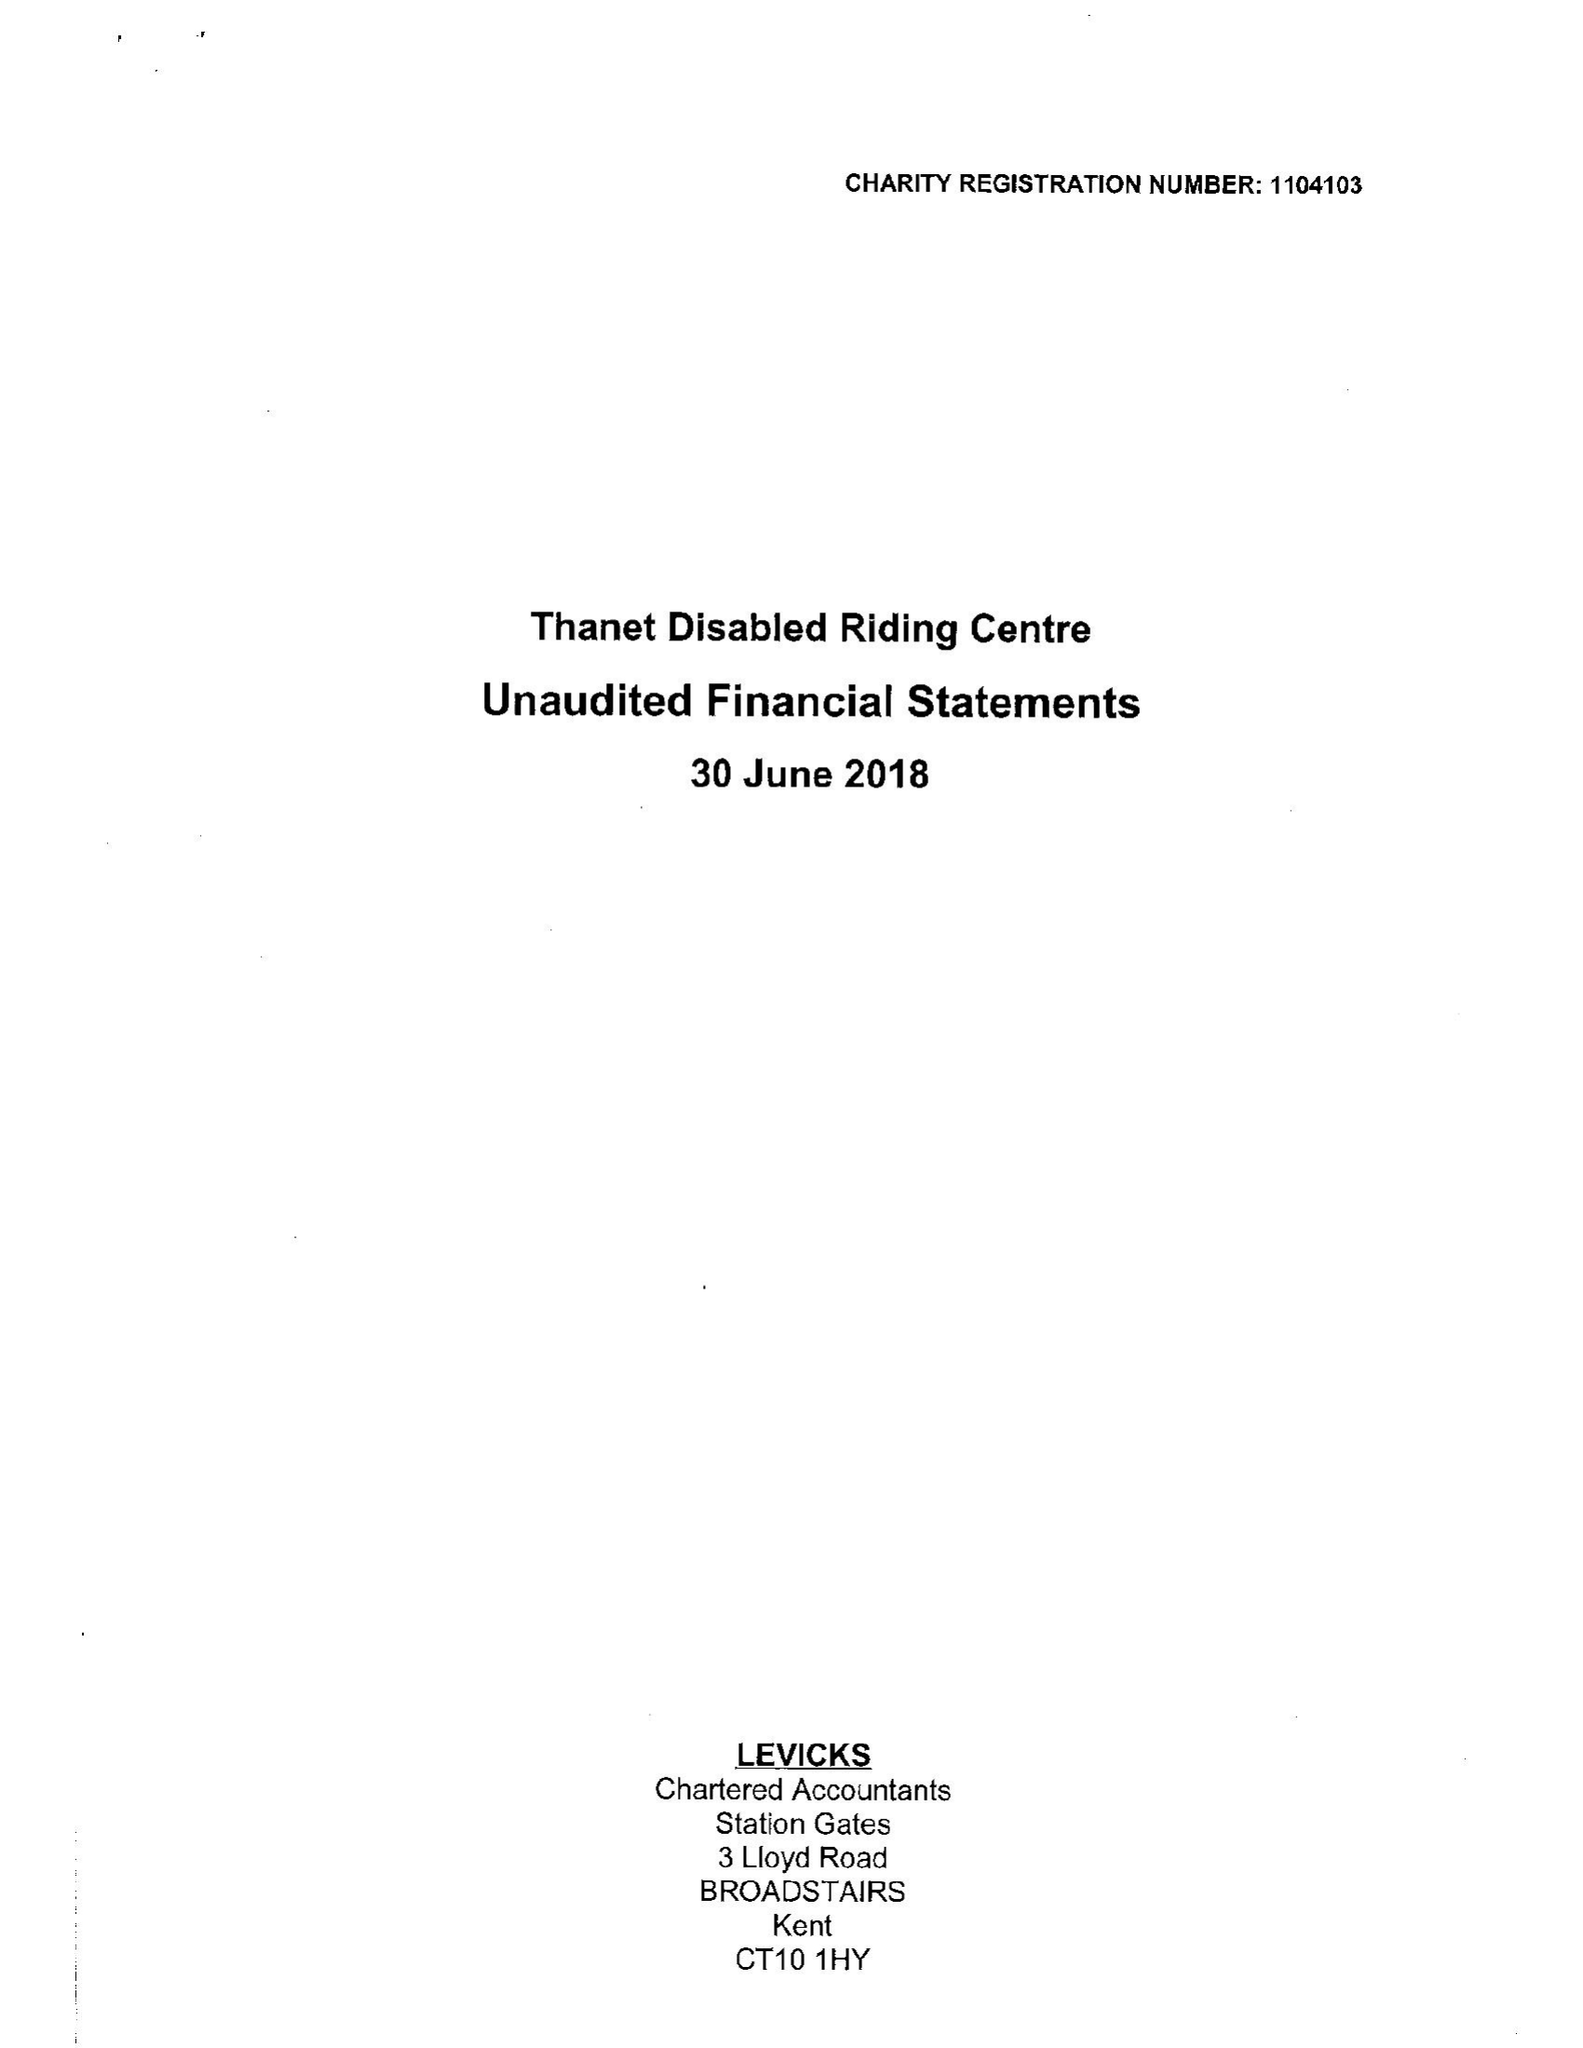What is the value for the report_date?
Answer the question using a single word or phrase. 2018-06-30 